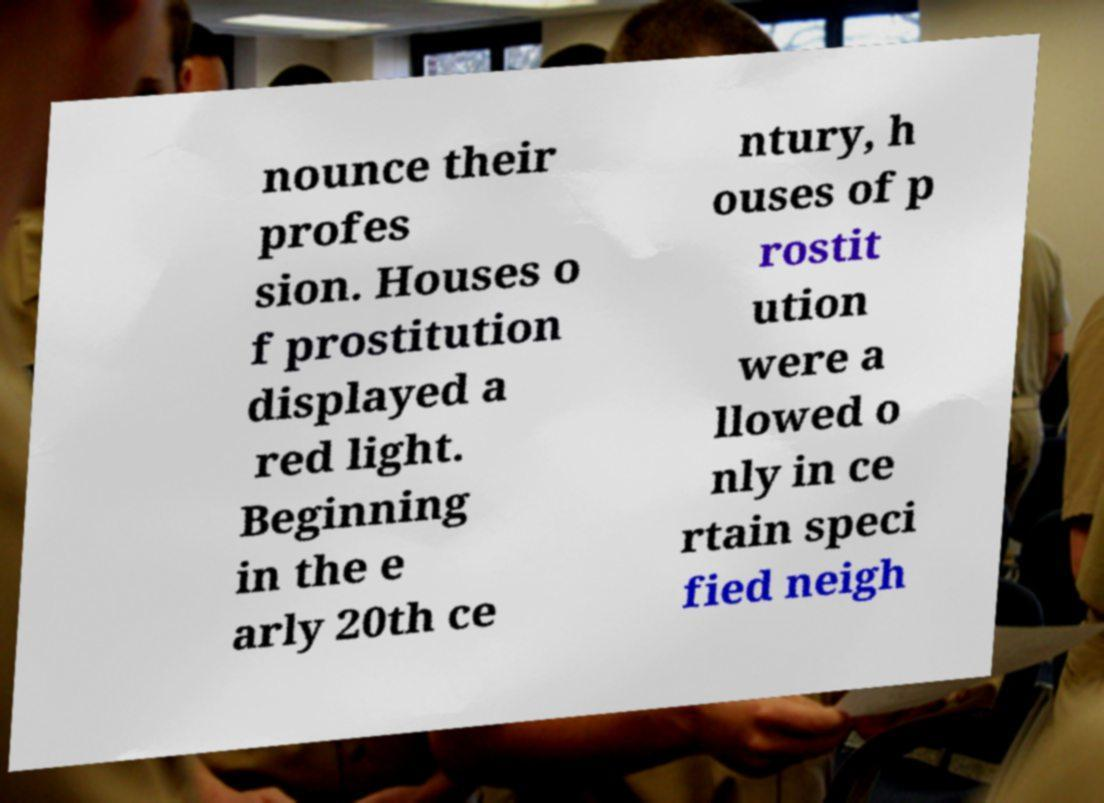For documentation purposes, I need the text within this image transcribed. Could you provide that? nounce their profes sion. Houses o f prostitution displayed a red light. Beginning in the e arly 20th ce ntury, h ouses of p rostit ution were a llowed o nly in ce rtain speci fied neigh 